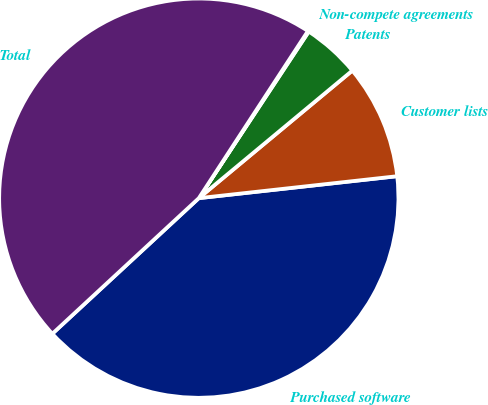<chart> <loc_0><loc_0><loc_500><loc_500><pie_chart><fcel>Purchased software<fcel>Customer lists<fcel>Patents<fcel>Non-compete agreements<fcel>Total<nl><fcel>39.87%<fcel>9.28%<fcel>4.68%<fcel>0.08%<fcel>46.09%<nl></chart> 